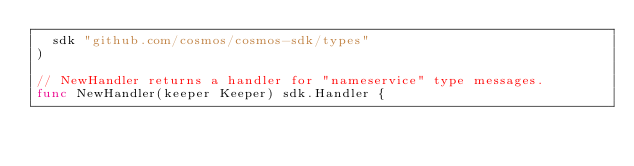Convert code to text. <code><loc_0><loc_0><loc_500><loc_500><_Go_>	sdk "github.com/cosmos/cosmos-sdk/types"
)

// NewHandler returns a handler for "nameservice" type messages.
func NewHandler(keeper Keeper) sdk.Handler {</code> 